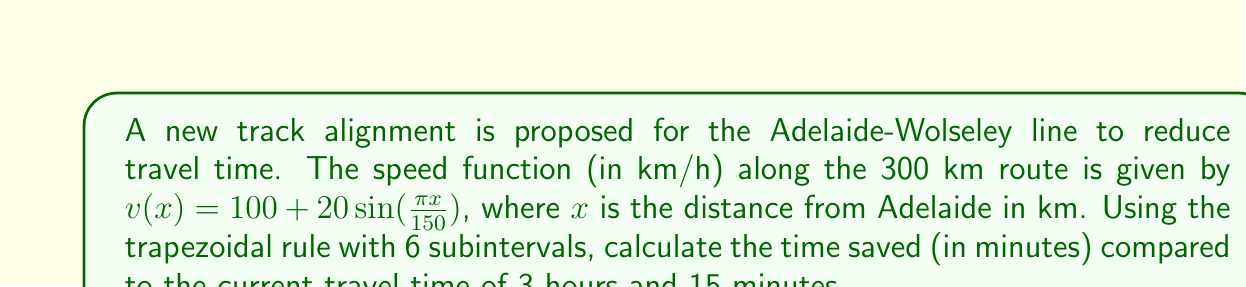What is the answer to this math problem? 1) To find the time saved, we need to calculate the new travel time using numerical integration.

2) The time taken is the integral of the reciprocal of velocity:

   $T = \int_0^{300} \frac{1}{v(x)} dx$

3) We'll use the trapezoidal rule with 6 subintervals. The formula is:

   $\int_a^b f(x)dx \approx \frac{h}{2}[f(x_0) + 2f(x_1) + 2f(x_2) + ... + 2f(x_{n-1}) + f(x_n)]$

   where $h = \frac{b-a}{n}$, $n = 6$, $a = 0$, $b = 300$

4) Calculate $h$: $h = \frac{300-0}{6} = 50$ km

5) Calculate function values:
   $f(x) = \frac{1}{v(x)} = \frac{1}{100 + 20\sin(\frac{\pi x}{150})}$

   $f(0) = \frac{1}{100} = 0.01$
   $f(50) = \frac{1}{100 + 20\sin(\frac{\pi}{3})} \approx 0.00866$
   $f(100) = \frac{1}{100 + 20\sin(\frac{2\pi}{3})} \approx 0.00866$
   $f(150) = \frac{1}{100} = 0.01$
   $f(200) = \frac{1}{100 + 20\sin(\frac{4\pi}{3})} \approx 0.01183$
   $f(250) = \frac{1}{100 + 20\sin(\frac{5\pi}{3})} \approx 0.01183$
   $f(300) = \frac{1}{100} = 0.01$

6) Apply the trapezoidal rule:

   $T \approx \frac{50}{2}[0.01 + 2(0.00866 + 0.00866 + 0.01183 + 0.01183) + 0.01]$
   $  = 25[0.02 + 0.08196]$
   $  = 25 * 0.10196$
   $  = 2.549$ hours

7) Convert to minutes: $2.549 * 60 = 152.94$ minutes

8) Time saved: $3h15m - 152.94m = 195m - 152.94m = 42.06$ minutes
Answer: 42.06 minutes 